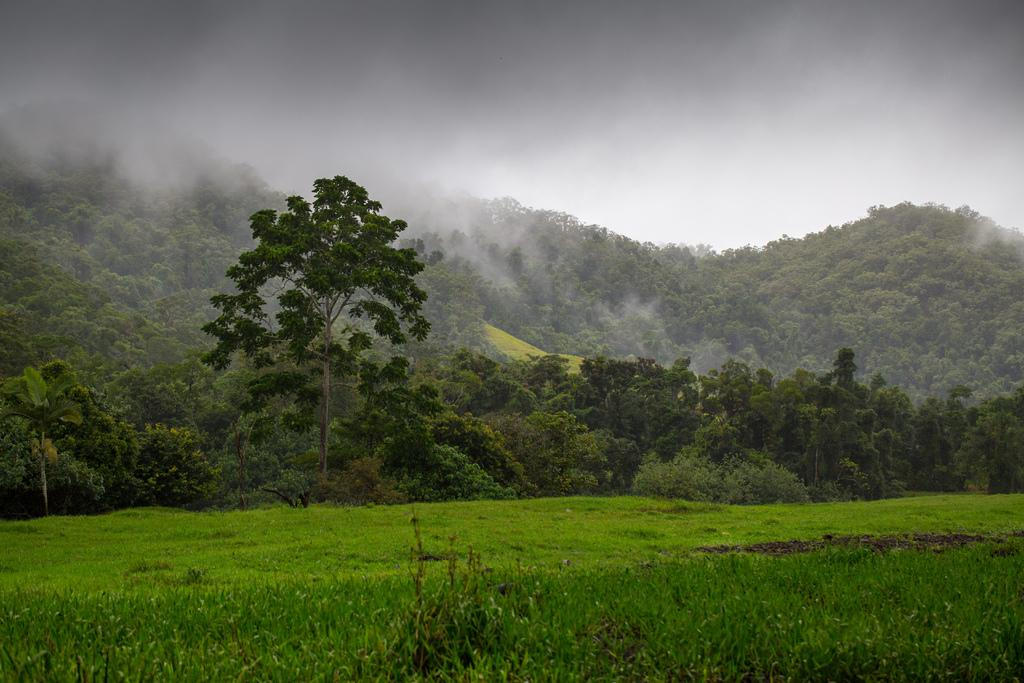What type of vegetation can be seen in the image? There is grass in the image. What other natural elements are present in the image? There are many trees in the image. What can be seen in the background of the image? The sky is visible in the background of the image, and there is fog present as well. What direction is the peace sign pointing in the image? There is no peace sign present in the image. 